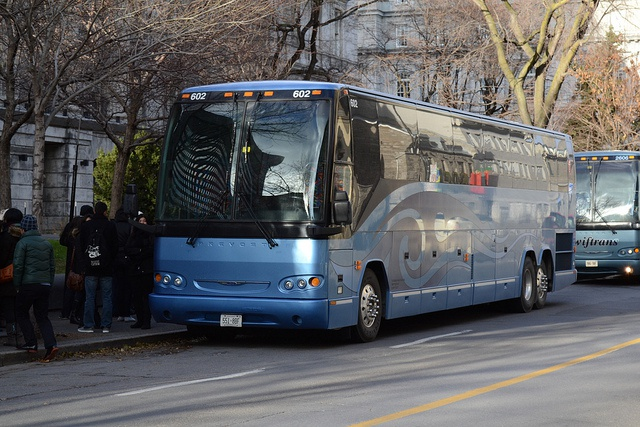Describe the objects in this image and their specific colors. I can see bus in purple, black, gray, darkgray, and blue tones, bus in purple, darkgray, gray, black, and white tones, people in purple, black, and darkblue tones, people in purple, black, gray, darkgreen, and darkgray tones, and people in purple, black, darkblue, and gray tones in this image. 